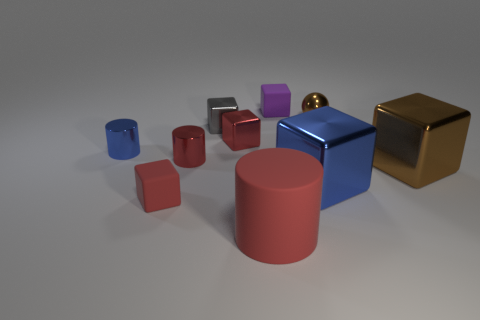Subtract all blue cubes. How many cubes are left? 5 Subtract all tiny red shiny blocks. How many blocks are left? 5 Subtract all brown blocks. Subtract all blue balls. How many blocks are left? 5 Subtract all balls. How many objects are left? 9 Add 2 purple objects. How many purple objects exist? 3 Subtract 0 red spheres. How many objects are left? 10 Subtract all blue metal cylinders. Subtract all large shiny blocks. How many objects are left? 7 Add 9 big red rubber cylinders. How many big red rubber cylinders are left? 10 